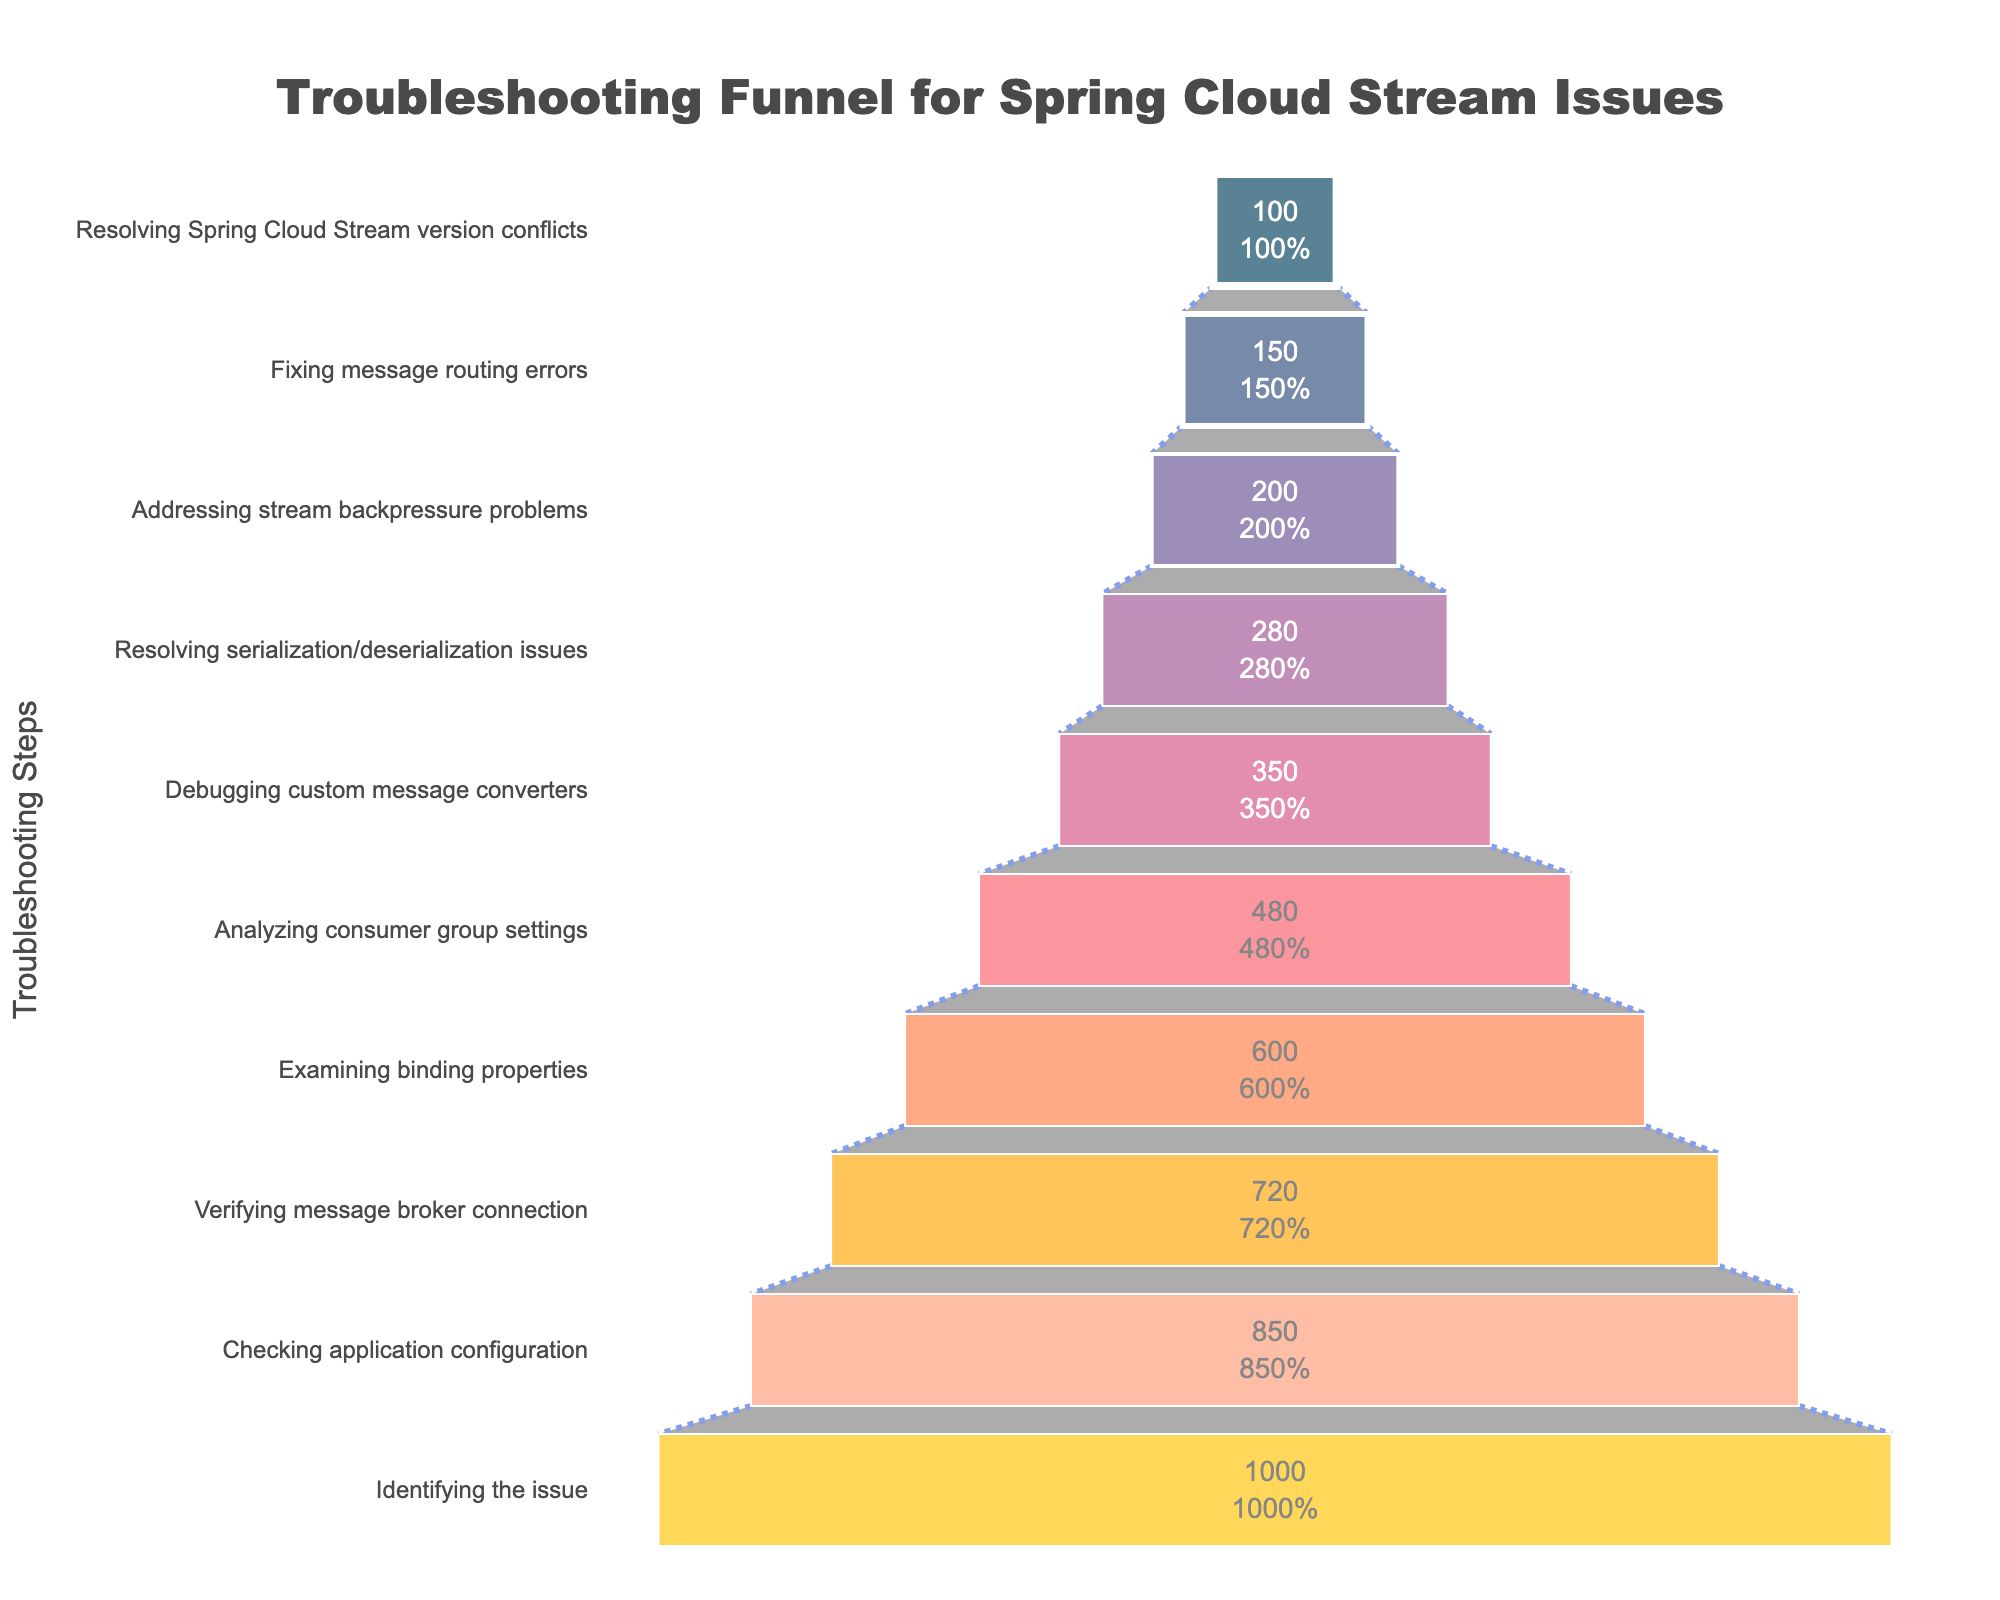What is the title of the funnel chart? The title of the chart is displayed at the top and reads "Troubleshooting Funnel for Spring Cloud Stream Issues".
Answer: Troubleshooting Funnel for Spring Cloud Stream Issues How many users encounter the "Checking application configuration" step? The number of users for each step is indicated along the x-axis; for the "Checking application configuration" step, the value is 850.
Answer: 850 Which step has the least number of users? By looking at the y-axis from top to bottom, the step "Resolving Spring Cloud Stream version conflicts" has the least number of users, with a value of 100.
Answer: Resolving Spring Cloud Stream version conflicts How many users successfully resolve serialization/deserialization issues? The chart shows that 280 users are dealing with "Resolving serialization/deserialization issues".
Answer: 280 What is the percentage of users from the initial step that reach "Debugging custom message converters"? To find the percentage, divide the number of users at the "Debugging custom message converters" step (350) by the initial number of users (1000) and multiply by 100. This results in (350/1000)*100 = 35%.
Answer: 35% Which step sees the largest drop in user count from the previous step? Compare the drop in user counts between adjacent steps to find the largest difference. "Debugging custom message converters" drops from 480 users at "Analyzing consumer group settings" to 350 users, a decrease of 130. This is the largest drop in the chart.
Answer: Debugging custom message converters Are there more users having issues with "Analyzing consumer group settings" or "Checking application configuration"? Comparing the two steps, "Checking application configuration" has 850 users and "Analyzing consumer group settings" has 480 users. Thus, more users have issues with "Checking application configuration".
Answer: Checking application configuration What is the total number of users from "Examining binding properties" to the final step? Add the number of users starting from the "Examining binding properties" step: 600 + 480 + 350 + 280 + 200 + 150 + 100 = 2160 users in total.
Answer: 2160 On which step do exactly half of the initial users remain? Half of the initial users (1000) is 500. The step closest to this number is "Analyzing consumer group settings" with 480 users.
Answer: Analyzing consumer group settings 